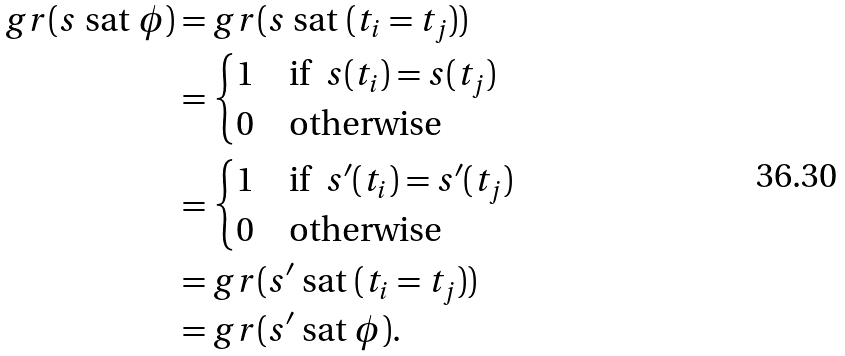Convert formula to latex. <formula><loc_0><loc_0><loc_500><loc_500>g r ( s \ \text {sat} \ \phi ) & = g r ( s \ \text {sat} \ ( t _ { i } = t _ { j } ) ) \\ & = \begin{cases} 1 & \text {if} \ \ s ( t _ { i } ) = s ( t _ { j } ) \\ 0 & \text {otherwise} \end{cases} \\ & = \begin{cases} 1 & \text {if} \ \ s ^ { \prime } ( t _ { i } ) = s ^ { \prime } ( t _ { j } ) \\ 0 & \text {otherwise} \end{cases} \\ & = g r ( s ^ { \prime } \ \text {sat} \ ( t _ { i } = t _ { j } ) ) \\ & = g r ( s ^ { \prime } \ \text {sat} \ \phi ) .</formula> 